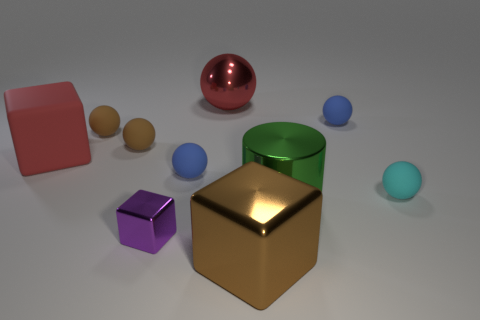Subtract all blue blocks. Subtract all blue spheres. How many blocks are left? 3 Subtract all purple cubes. How many purple spheres are left? 0 Add 1 reds. How many purples exist? 0 Subtract all tiny cyan things. Subtract all large red matte cubes. How many objects are left? 8 Add 9 big cylinders. How many big cylinders are left? 10 Add 9 large brown shiny cubes. How many large brown shiny cubes exist? 10 Subtract all brown spheres. How many spheres are left? 4 Subtract all tiny spheres. How many spheres are left? 1 Subtract 0 green blocks. How many objects are left? 10 How many blue spheres must be subtracted to get 1 blue spheres? 1 